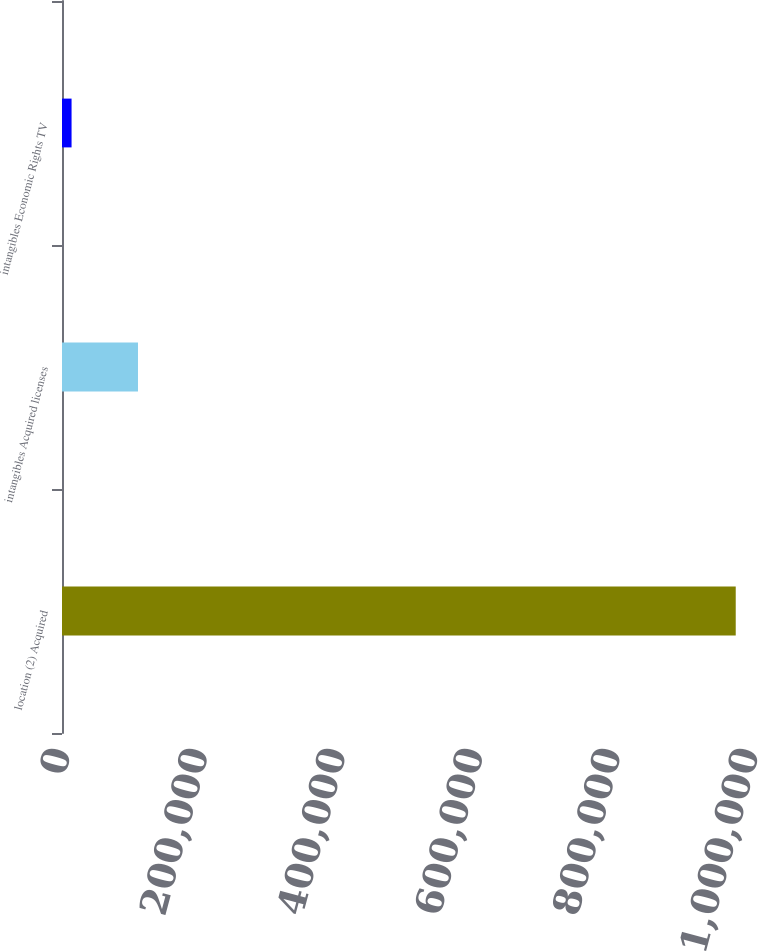Convert chart to OTSL. <chart><loc_0><loc_0><loc_500><loc_500><bar_chart><fcel>location (2) Acquired<fcel>intangibles Acquired licenses<fcel>intangibles Economic Rights TV<nl><fcel>979264<fcel>110438<fcel>13902<nl></chart> 